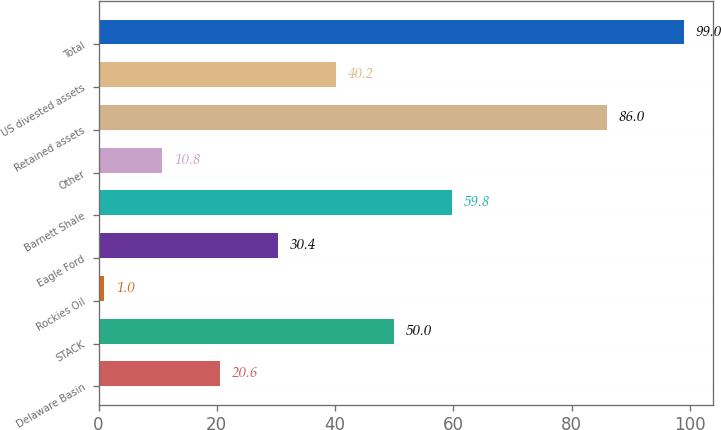<chart> <loc_0><loc_0><loc_500><loc_500><bar_chart><fcel>Delaware Basin<fcel>STACK<fcel>Rockies Oil<fcel>Eagle Ford<fcel>Barnett Shale<fcel>Other<fcel>Retained assets<fcel>US divested assets<fcel>Total<nl><fcel>20.6<fcel>50<fcel>1<fcel>30.4<fcel>59.8<fcel>10.8<fcel>86<fcel>40.2<fcel>99<nl></chart> 